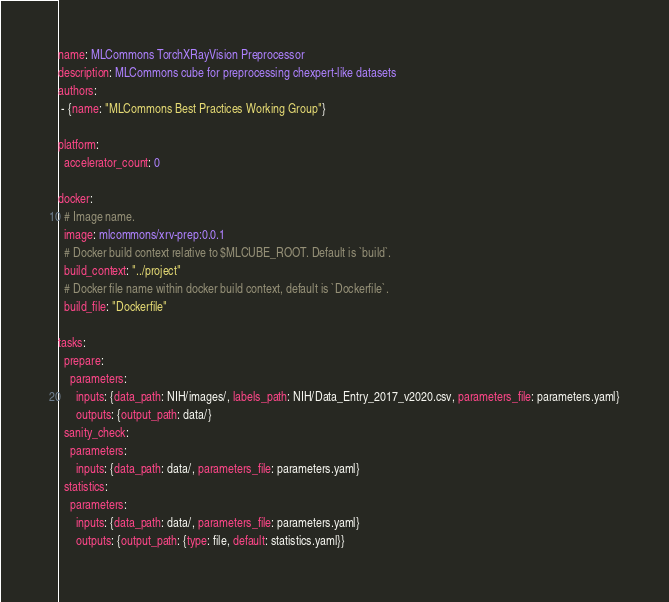<code> <loc_0><loc_0><loc_500><loc_500><_YAML_>name: MLCommons TorchXRayVision Preprocessor
description: MLCommons cube for preprocessing chexpert-like datasets
authors:
 - {name: "MLCommons Best Practices Working Group"}

platform:
  accelerator_count: 0

docker:
  # Image name.
  image: mlcommons/xrv-prep:0.0.1
  # Docker build context relative to $MLCUBE_ROOT. Default is `build`.
  build_context: "../project"
  # Docker file name within docker build context, default is `Dockerfile`.
  build_file: "Dockerfile"

tasks:
  prepare:
    parameters:
      inputs: {data_path: NIH/images/, labels_path: NIH/Data_Entry_2017_v2020.csv, parameters_file: parameters.yaml}
      outputs: {output_path: data/}
  sanity_check:
    parameters:
      inputs: {data_path: data/, parameters_file: parameters.yaml}
  statistics:
    parameters:
      inputs: {data_path: data/, parameters_file: parameters.yaml}
      outputs: {output_path: {type: file, default: statistics.yaml}}</code> 